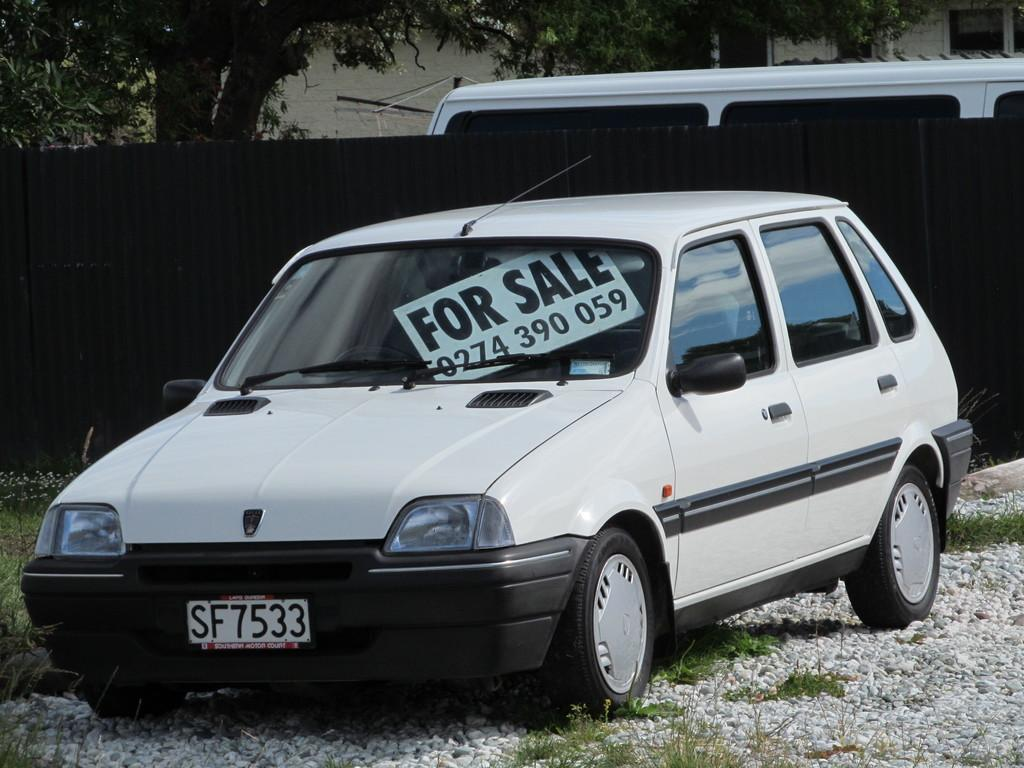<image>
Summarize the visual content of the image. A car for sale with a front tag number SF7533. 